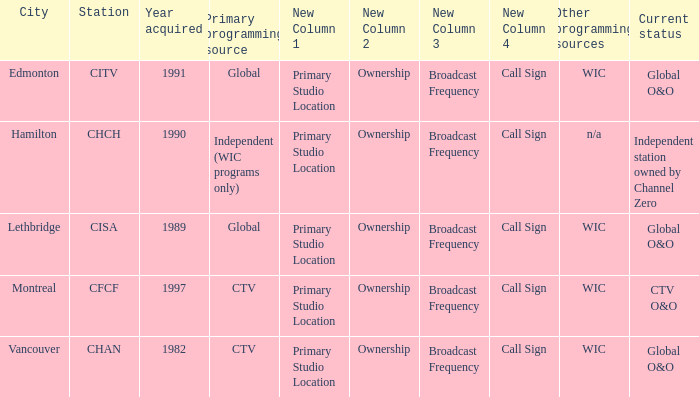How many channels were gained in 1997 1.0. 